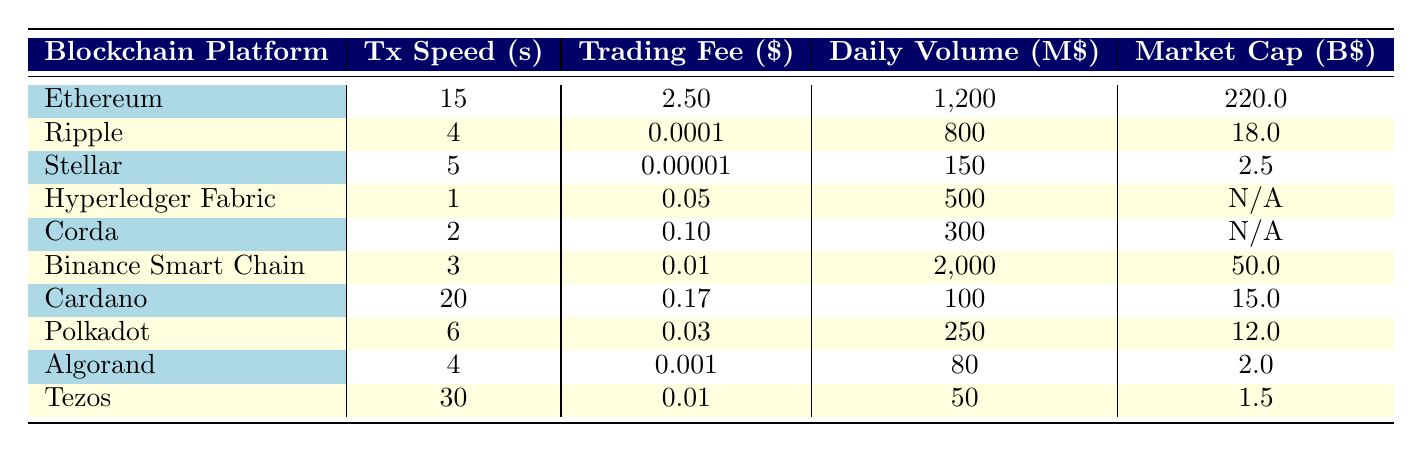What is the lowest trading fee in the table? The lowest trading fee in the table is listed next to Stellar, which has a fee of 0.00001 USD.
Answer: 0.00001 USD Which blockchain platform has the highest daily volume? The blockchain platform with the highest daily volume is Binance Smart Chain, showing a volume of 2000 million USD.
Answer: 2000 million USD What is the average transaction speed of all blockchain platforms listed? To calculate the average transaction speed, sum the speeds: (15 + 4 + 5 + 1 + 2 + 3 + 20 + 6 + 4 + 30) = 90 seconds. Dividing by 10 platforms gives an average of 9 seconds.
Answer: 9 seconds Is there a blockchain platform with a market cap listed as "N/A"? Yes, both Hyperledger Fabric and Corda show "N/A" for market cap.
Answer: Yes Which blockchain platform has the highest trading fee and what is that fee? The blockchain platform with the highest trading fee is Ethereum, which charges 2.50 USD per transaction.
Answer: Ethereum, 2.50 USD What is the total combined market cap of the blockchain platforms that have a market cap listed? The market cap values that are available are 220 (Ethereum) + 18 (Ripple) + 2.5 (Stellar) + 50 (Binance Smart Chain) + 15 (Cardano) + 12 (Polkadot) + 2 (Algorand) + 1.5 (Tezos) = 321 million USD.
Answer: 321 million USD Which blockchain platform utilizes smart contracts? Ethereum is the blockchain platform that is used for smart contracts.
Answer: Ethereum How many blockchain platforms have a transaction speed of less than 5 seconds? The platforms with a transaction speed of less than 5 seconds are Ripple (4 seconds) and Hyperledger Fabric (1 second), totaling 2 platforms.
Answer: 2 platforms 